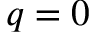<formula> <loc_0><loc_0><loc_500><loc_500>q = 0</formula> 